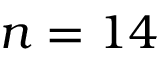<formula> <loc_0><loc_0><loc_500><loc_500>n = 1 4</formula> 